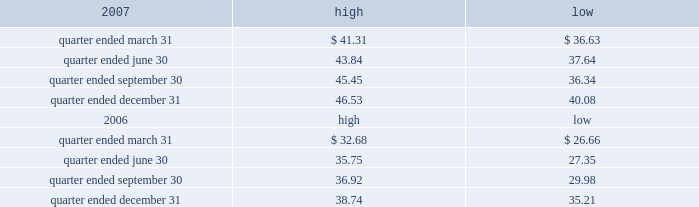Part ii item 5 .
Market for registrant 2019s common equity , related stockholder matters and issuer purchases of equity securities the table presents reported quarterly high and low per share sale prices of our class a common stock on the new york stock exchange ( 201cnyse 201d ) for the years 2007 and 2006. .
On february 29 , 2008 , the closing price of our class a common stock was $ 38.44 per share as reported on the nyse .
As of february 29 , 2008 , we had 395748826 outstanding shares of class a common stock and 528 registered holders .
Dividends we have never paid a dividend on any class of our common stock .
We anticipate that we may retain future earnings , if any , to fund the development and growth of our business .
The indentures governing our 7.50% ( 7.50 % ) senior notes due 2012 ( 201c7.50% ( 201c7.50 % ) notes 201d ) and our 7.125% ( 7.125 % ) senior notes due 2012 ( 201c7.125% ( 201c7.125 % ) notes 201d ) may prohibit us from paying dividends to our stockholders unless we satisfy certain financial covenants .
The loan agreement for our revolving credit facility and the indentures governing the terms of our 7.50% ( 7.50 % ) notes and 7.125% ( 7.125 % ) notes contain covenants that restrict our ability to pay dividends unless certain financial covenants are satisfied .
In addition , while spectrasite and its subsidiaries are classified as unrestricted subsidiaries under the indentures for our 7.50% ( 7.50 % ) notes and 7.125% ( 7.125 % ) notes , certain of spectrasite 2019s subsidiaries are subject to restrictions on the amount of cash that they can distribute to us under the loan agreement related to our securitization .
For more information about the restrictions under the loan agreement for the revolving credit facility , our notes indentures and the loan agreement related to the securitization , see item 7 of this annual report under the caption 201cmanagement 2019s discussion and analysis of financial condition and results of operations 2014liquidity and capital resources 2014factors affecting sources of liquidity 201d and note 3 to our consolidated financial statements included in this annual report. .
What was the fair value of class a stockholders equity at february 29 , 2008?\\n .? 
Computations: (38.44 * 395748826)
Answer: 15212584871.44. 